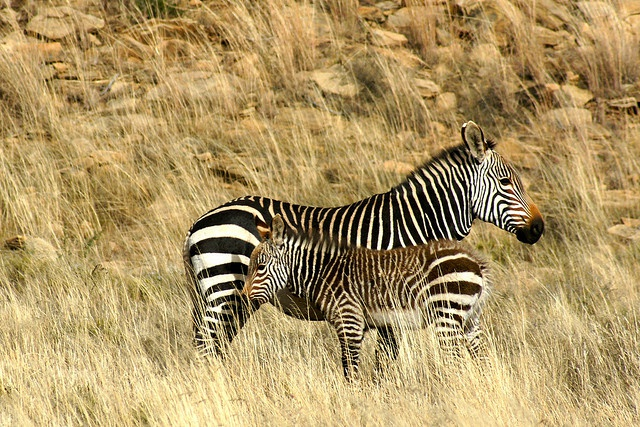Describe the objects in this image and their specific colors. I can see zebra in olive, black, beige, khaki, and tan tones and zebra in olive, black, khaki, and tan tones in this image. 